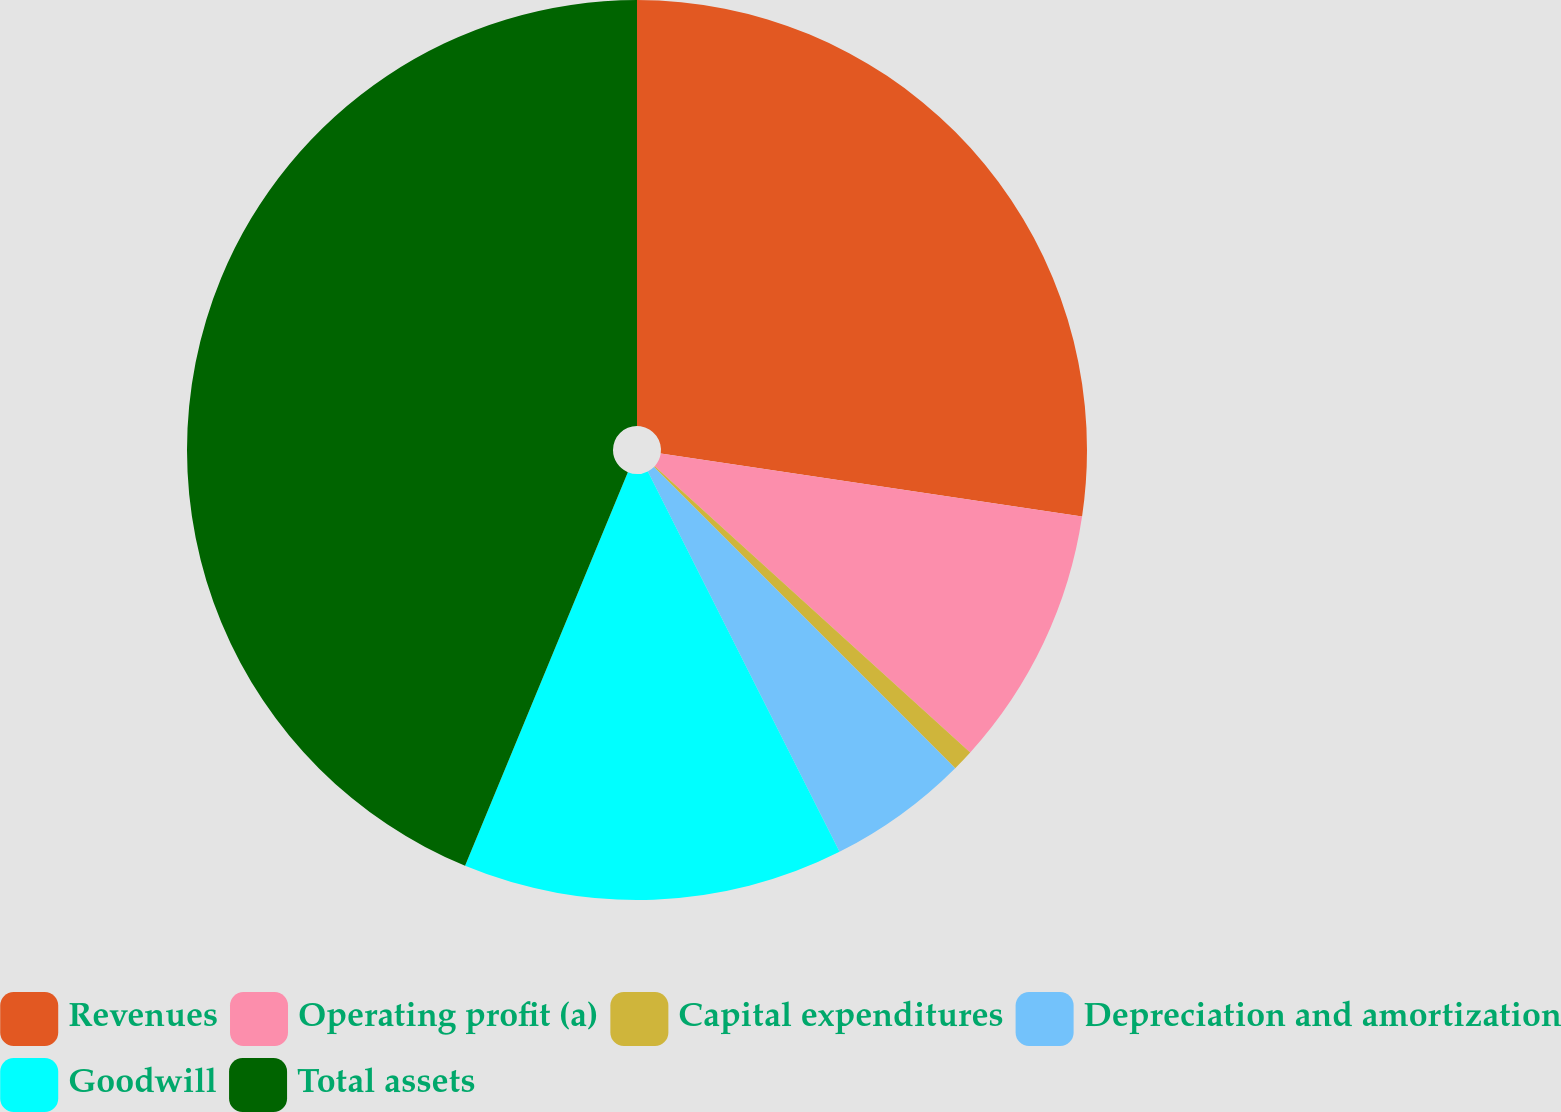<chart> <loc_0><loc_0><loc_500><loc_500><pie_chart><fcel>Revenues<fcel>Operating profit (a)<fcel>Capital expenditures<fcel>Depreciation and amortization<fcel>Goodwill<fcel>Total assets<nl><fcel>27.36%<fcel>9.37%<fcel>0.77%<fcel>5.07%<fcel>13.67%<fcel>43.76%<nl></chart> 